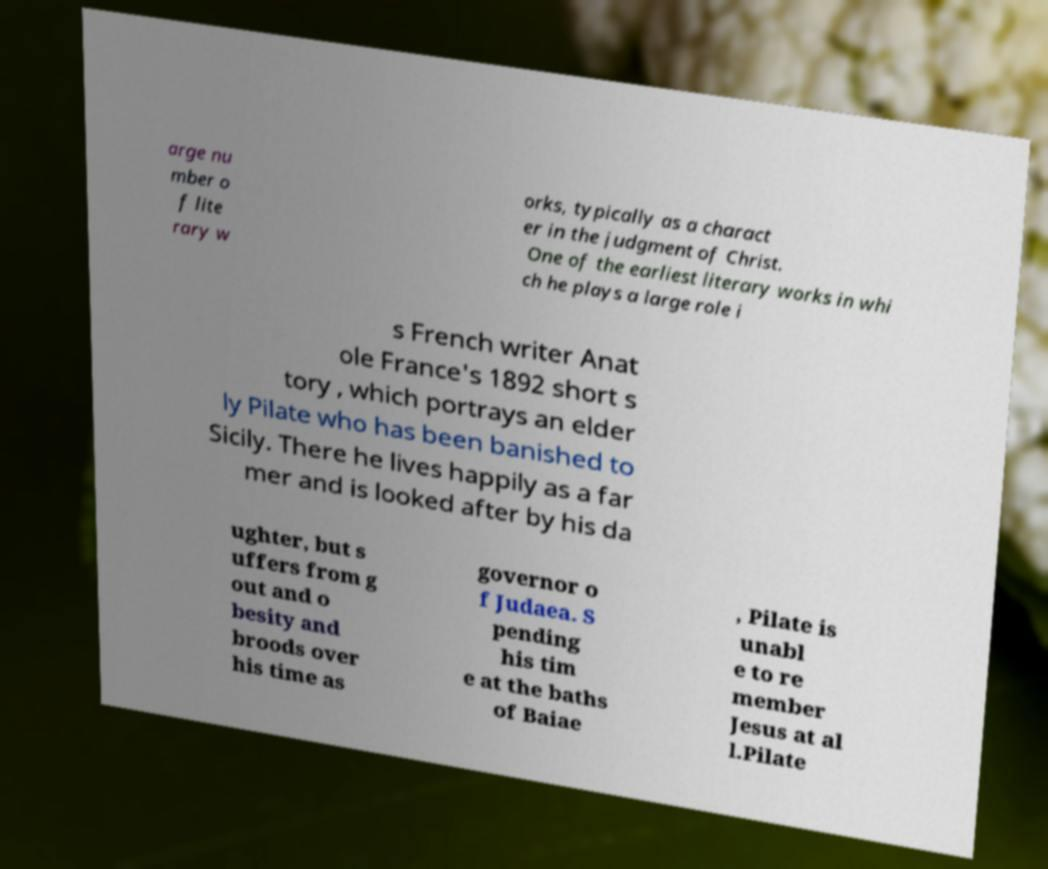There's text embedded in this image that I need extracted. Can you transcribe it verbatim? arge nu mber o f lite rary w orks, typically as a charact er in the judgment of Christ. One of the earliest literary works in whi ch he plays a large role i s French writer Anat ole France's 1892 short s tory , which portrays an elder ly Pilate who has been banished to Sicily. There he lives happily as a far mer and is looked after by his da ughter, but s uffers from g out and o besity and broods over his time as governor o f Judaea. S pending his tim e at the baths of Baiae , Pilate is unabl e to re member Jesus at al l.Pilate 